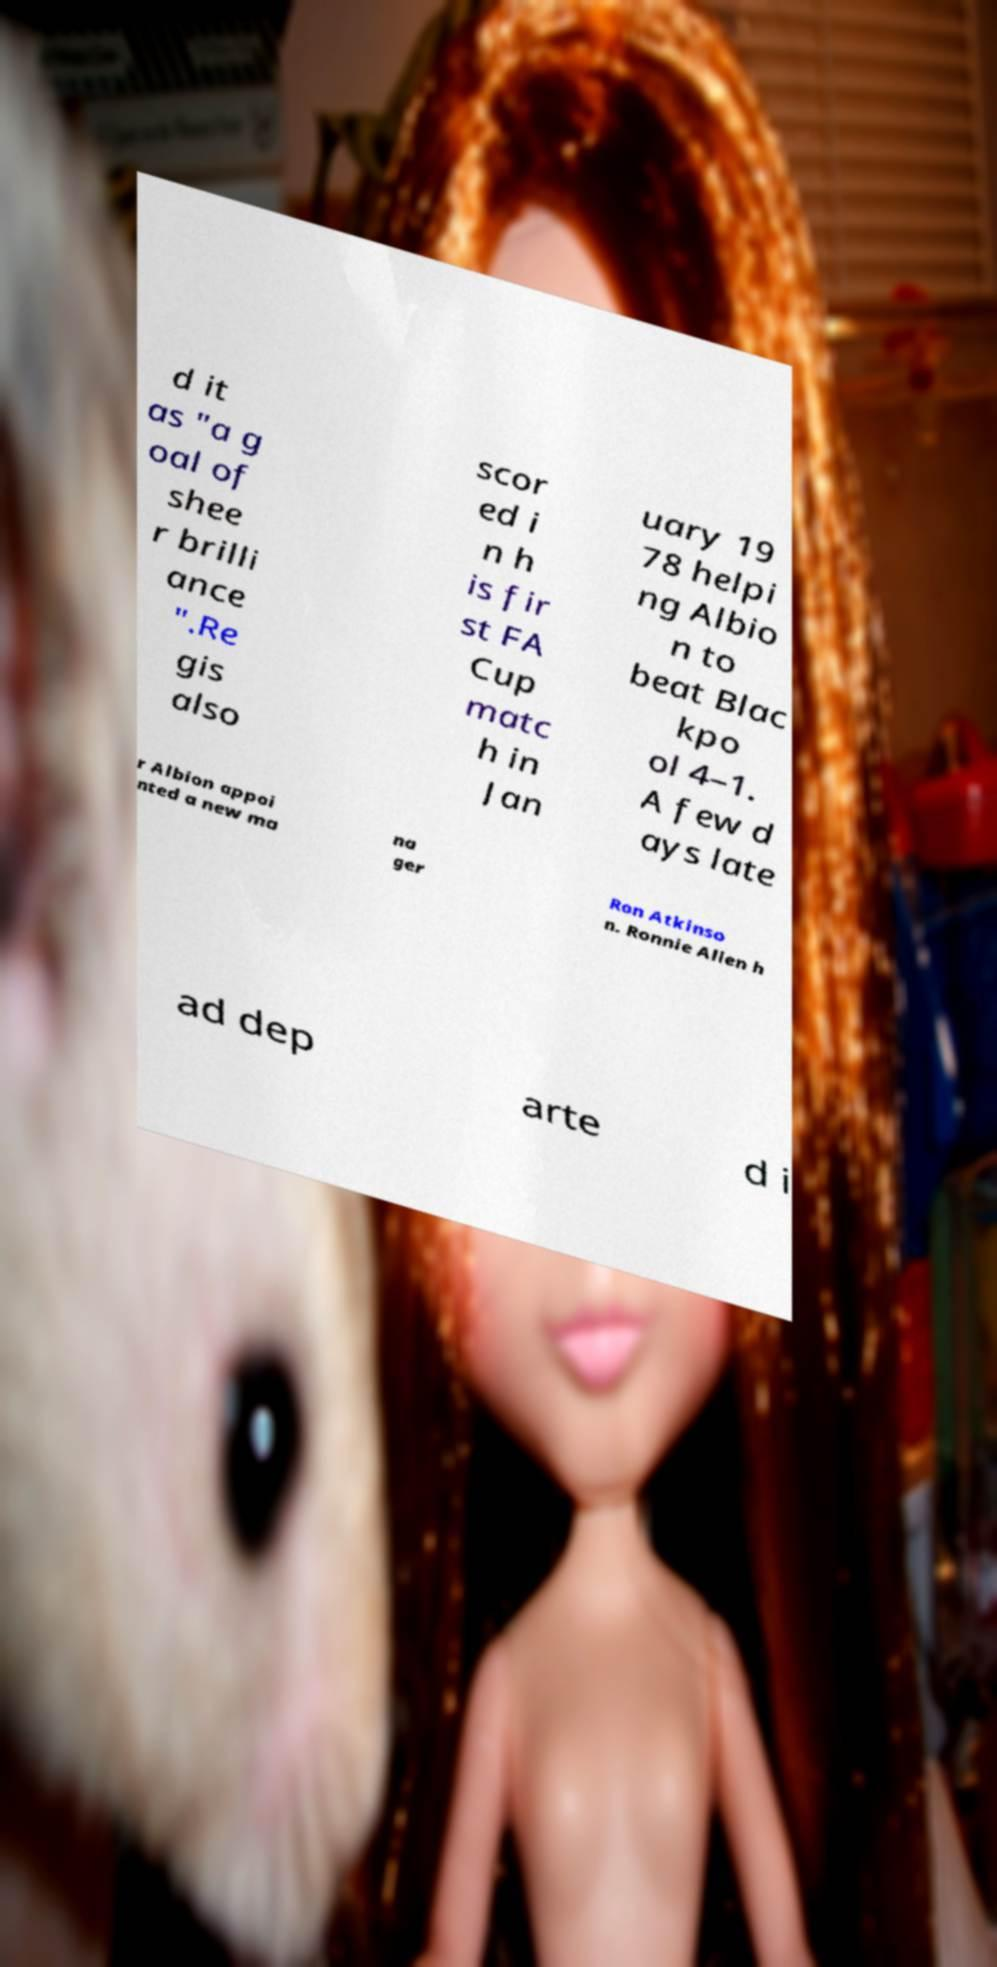I need the written content from this picture converted into text. Can you do that? d it as "a g oal of shee r brilli ance ".Re gis also scor ed i n h is fir st FA Cup matc h in Jan uary 19 78 helpi ng Albio n to beat Blac kpo ol 4–1. A few d ays late r Albion appoi nted a new ma na ger Ron Atkinso n. Ronnie Allen h ad dep arte d i 